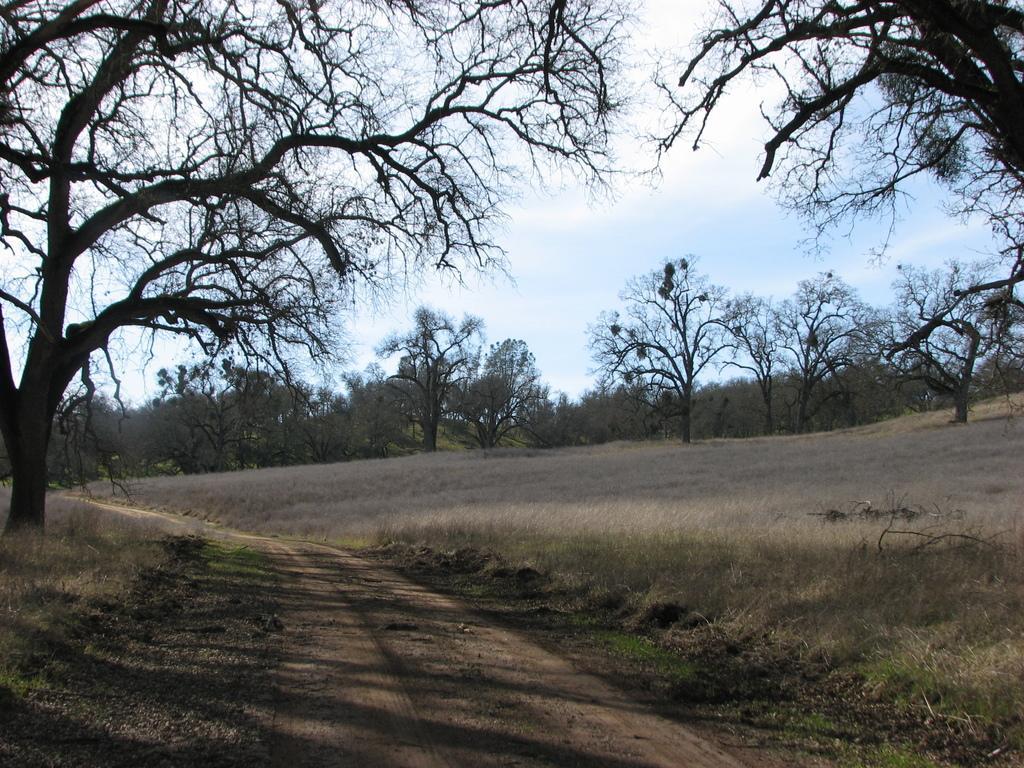Please provide a concise description of this image. In this image we can see path in the middle and to either side of the path we can see trees and grass on the ground. In the background there are trees and clouds in the sky. 